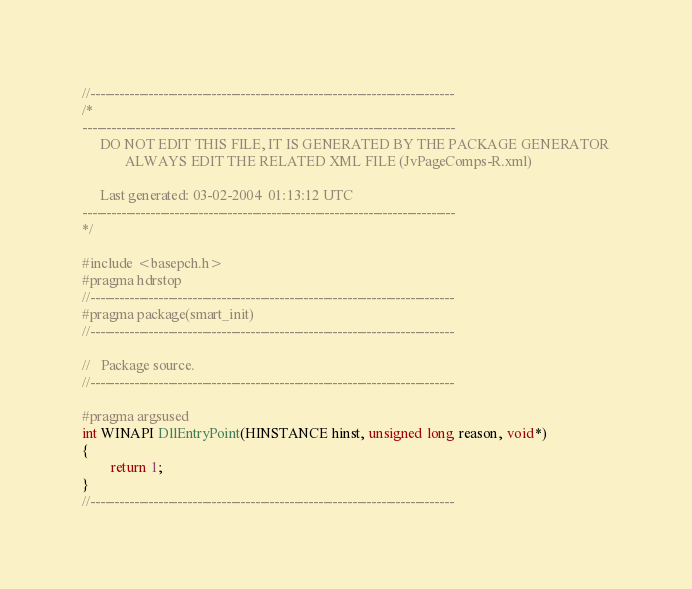<code> <loc_0><loc_0><loc_500><loc_500><_C++_>//---------------------------------------------------------------------------
/*
-----------------------------------------------------------------------------
     DO NOT EDIT THIS FILE, IT IS GENERATED BY THE PACKAGE GENERATOR
            ALWAYS EDIT THE RELATED XML FILE (JvPageComps-R.xml)
            
     Last generated: 03-02-2004  01:13:12 UTC     
-----------------------------------------------------------------------------
*/

#include <basepch.h>
#pragma hdrstop
//---------------------------------------------------------------------------
#pragma package(smart_init)
//---------------------------------------------------------------------------

//   Package source.
//---------------------------------------------------------------------------

#pragma argsused
int WINAPI DllEntryPoint(HINSTANCE hinst, unsigned long reason, void*)
{
        return 1;
}
//---------------------------------------------------------------------------

</code> 